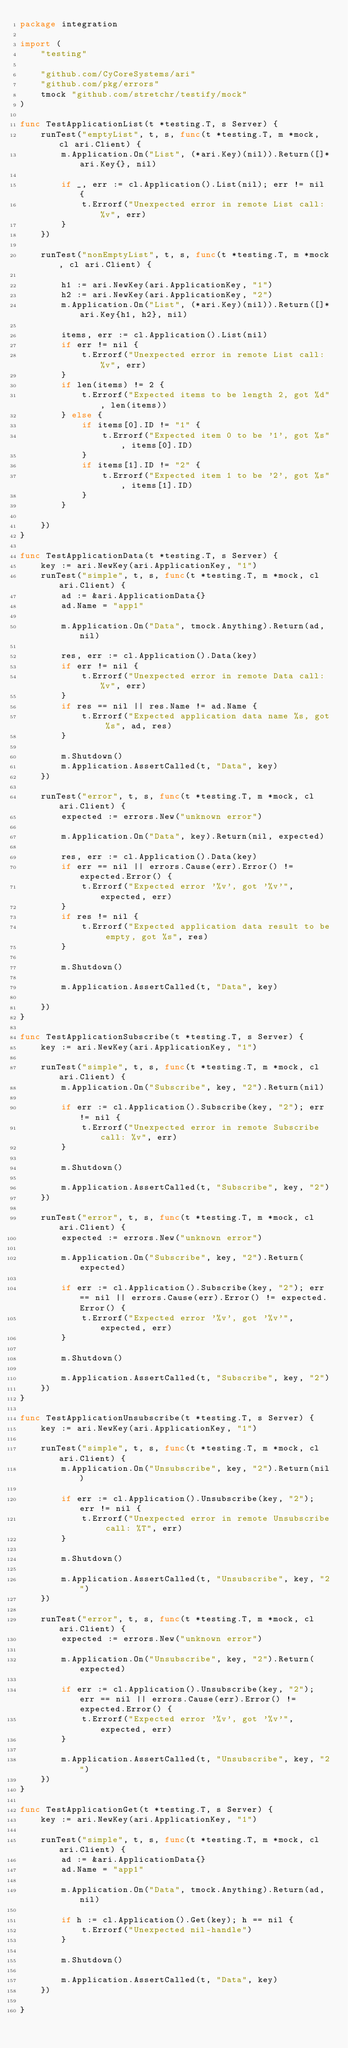<code> <loc_0><loc_0><loc_500><loc_500><_Go_>package integration

import (
	"testing"

	"github.com/CyCoreSystems/ari"
	"github.com/pkg/errors"
	tmock "github.com/stretchr/testify/mock"
)

func TestApplicationList(t *testing.T, s Server) {
	runTest("emptyList", t, s, func(t *testing.T, m *mock, cl ari.Client) {
		m.Application.On("List", (*ari.Key)(nil)).Return([]*ari.Key{}, nil)

		if _, err := cl.Application().List(nil); err != nil {
			t.Errorf("Unexpected error in remote List call: %v", err)
		}
	})

	runTest("nonEmptyList", t, s, func(t *testing.T, m *mock, cl ari.Client) {

		h1 := ari.NewKey(ari.ApplicationKey, "1")
		h2 := ari.NewKey(ari.ApplicationKey, "2")
		m.Application.On("List", (*ari.Key)(nil)).Return([]*ari.Key{h1, h2}, nil)

		items, err := cl.Application().List(nil)
		if err != nil {
			t.Errorf("Unexpected error in remote List call: %v", err)
		}
		if len(items) != 2 {
			t.Errorf("Expected items to be length 2, got %d", len(items))
		} else {
			if items[0].ID != "1" {
				t.Errorf("Expected item 0 to be '1', got %s", items[0].ID)
			}
			if items[1].ID != "2" {
				t.Errorf("Expected item 1 to be '2', got %s", items[1].ID)
			}
		}

	})
}

func TestApplicationData(t *testing.T, s Server) {
	key := ari.NewKey(ari.ApplicationKey, "1")
	runTest("simple", t, s, func(t *testing.T, m *mock, cl ari.Client) {
		ad := &ari.ApplicationData{}
		ad.Name = "app1"

		m.Application.On("Data", tmock.Anything).Return(ad, nil)

		res, err := cl.Application().Data(key)
		if err != nil {
			t.Errorf("Unexpected error in remote Data call: %v", err)
		}
		if res == nil || res.Name != ad.Name {
			t.Errorf("Expected application data name %s, got %s", ad, res)
		}

		m.Shutdown()
		m.Application.AssertCalled(t, "Data", key)
	})

	runTest("error", t, s, func(t *testing.T, m *mock, cl ari.Client) {
		expected := errors.New("unknown error")

		m.Application.On("Data", key).Return(nil, expected)

		res, err := cl.Application().Data(key)
		if err == nil || errors.Cause(err).Error() != expected.Error() {
			t.Errorf("Expected error '%v', got '%v'", expected, err)
		}
		if res != nil {
			t.Errorf("Expected application data result to be empty, got %s", res)
		}

		m.Shutdown()

		m.Application.AssertCalled(t, "Data", key)

	})
}

func TestApplicationSubscribe(t *testing.T, s Server) {
	key := ari.NewKey(ari.ApplicationKey, "1")

	runTest("simple", t, s, func(t *testing.T, m *mock, cl ari.Client) {
		m.Application.On("Subscribe", key, "2").Return(nil)

		if err := cl.Application().Subscribe(key, "2"); err != nil {
			t.Errorf("Unexpected error in remote Subscribe call: %v", err)
		}

		m.Shutdown()

		m.Application.AssertCalled(t, "Subscribe", key, "2")
	})

	runTest("error", t, s, func(t *testing.T, m *mock, cl ari.Client) {
		expected := errors.New("unknown error")

		m.Application.On("Subscribe", key, "2").Return(expected)

		if err := cl.Application().Subscribe(key, "2"); err == nil || errors.Cause(err).Error() != expected.Error() {
			t.Errorf("Expected error '%v', got '%v'", expected, err)
		}

		m.Shutdown()

		m.Application.AssertCalled(t, "Subscribe", key, "2")
	})
}

func TestApplicationUnsubscribe(t *testing.T, s Server) {
	key := ari.NewKey(ari.ApplicationKey, "1")

	runTest("simple", t, s, func(t *testing.T, m *mock, cl ari.Client) {
		m.Application.On("Unsubscribe", key, "2").Return(nil)

		if err := cl.Application().Unsubscribe(key, "2"); err != nil {
			t.Errorf("Unexpected error in remote Unsubscribe call: %T", err)
		}

		m.Shutdown()

		m.Application.AssertCalled(t, "Unsubscribe", key, "2")
	})

	runTest("error", t, s, func(t *testing.T, m *mock, cl ari.Client) {
		expected := errors.New("unknown error")

		m.Application.On("Unsubscribe", key, "2").Return(expected)

		if err := cl.Application().Unsubscribe(key, "2"); err == nil || errors.Cause(err).Error() != expected.Error() {
			t.Errorf("Expected error '%v', got '%v'", expected, err)
		}

		m.Application.AssertCalled(t, "Unsubscribe", key, "2")
	})
}

func TestApplicationGet(t *testing.T, s Server) {
	key := ari.NewKey(ari.ApplicationKey, "1")

	runTest("simple", t, s, func(t *testing.T, m *mock, cl ari.Client) {
		ad := &ari.ApplicationData{}
		ad.Name = "app1"

		m.Application.On("Data", tmock.Anything).Return(ad, nil)

		if h := cl.Application().Get(key); h == nil {
			t.Errorf("Unexpected nil-handle")
		}

		m.Shutdown()

		m.Application.AssertCalled(t, "Data", key)
	})

}
</code> 